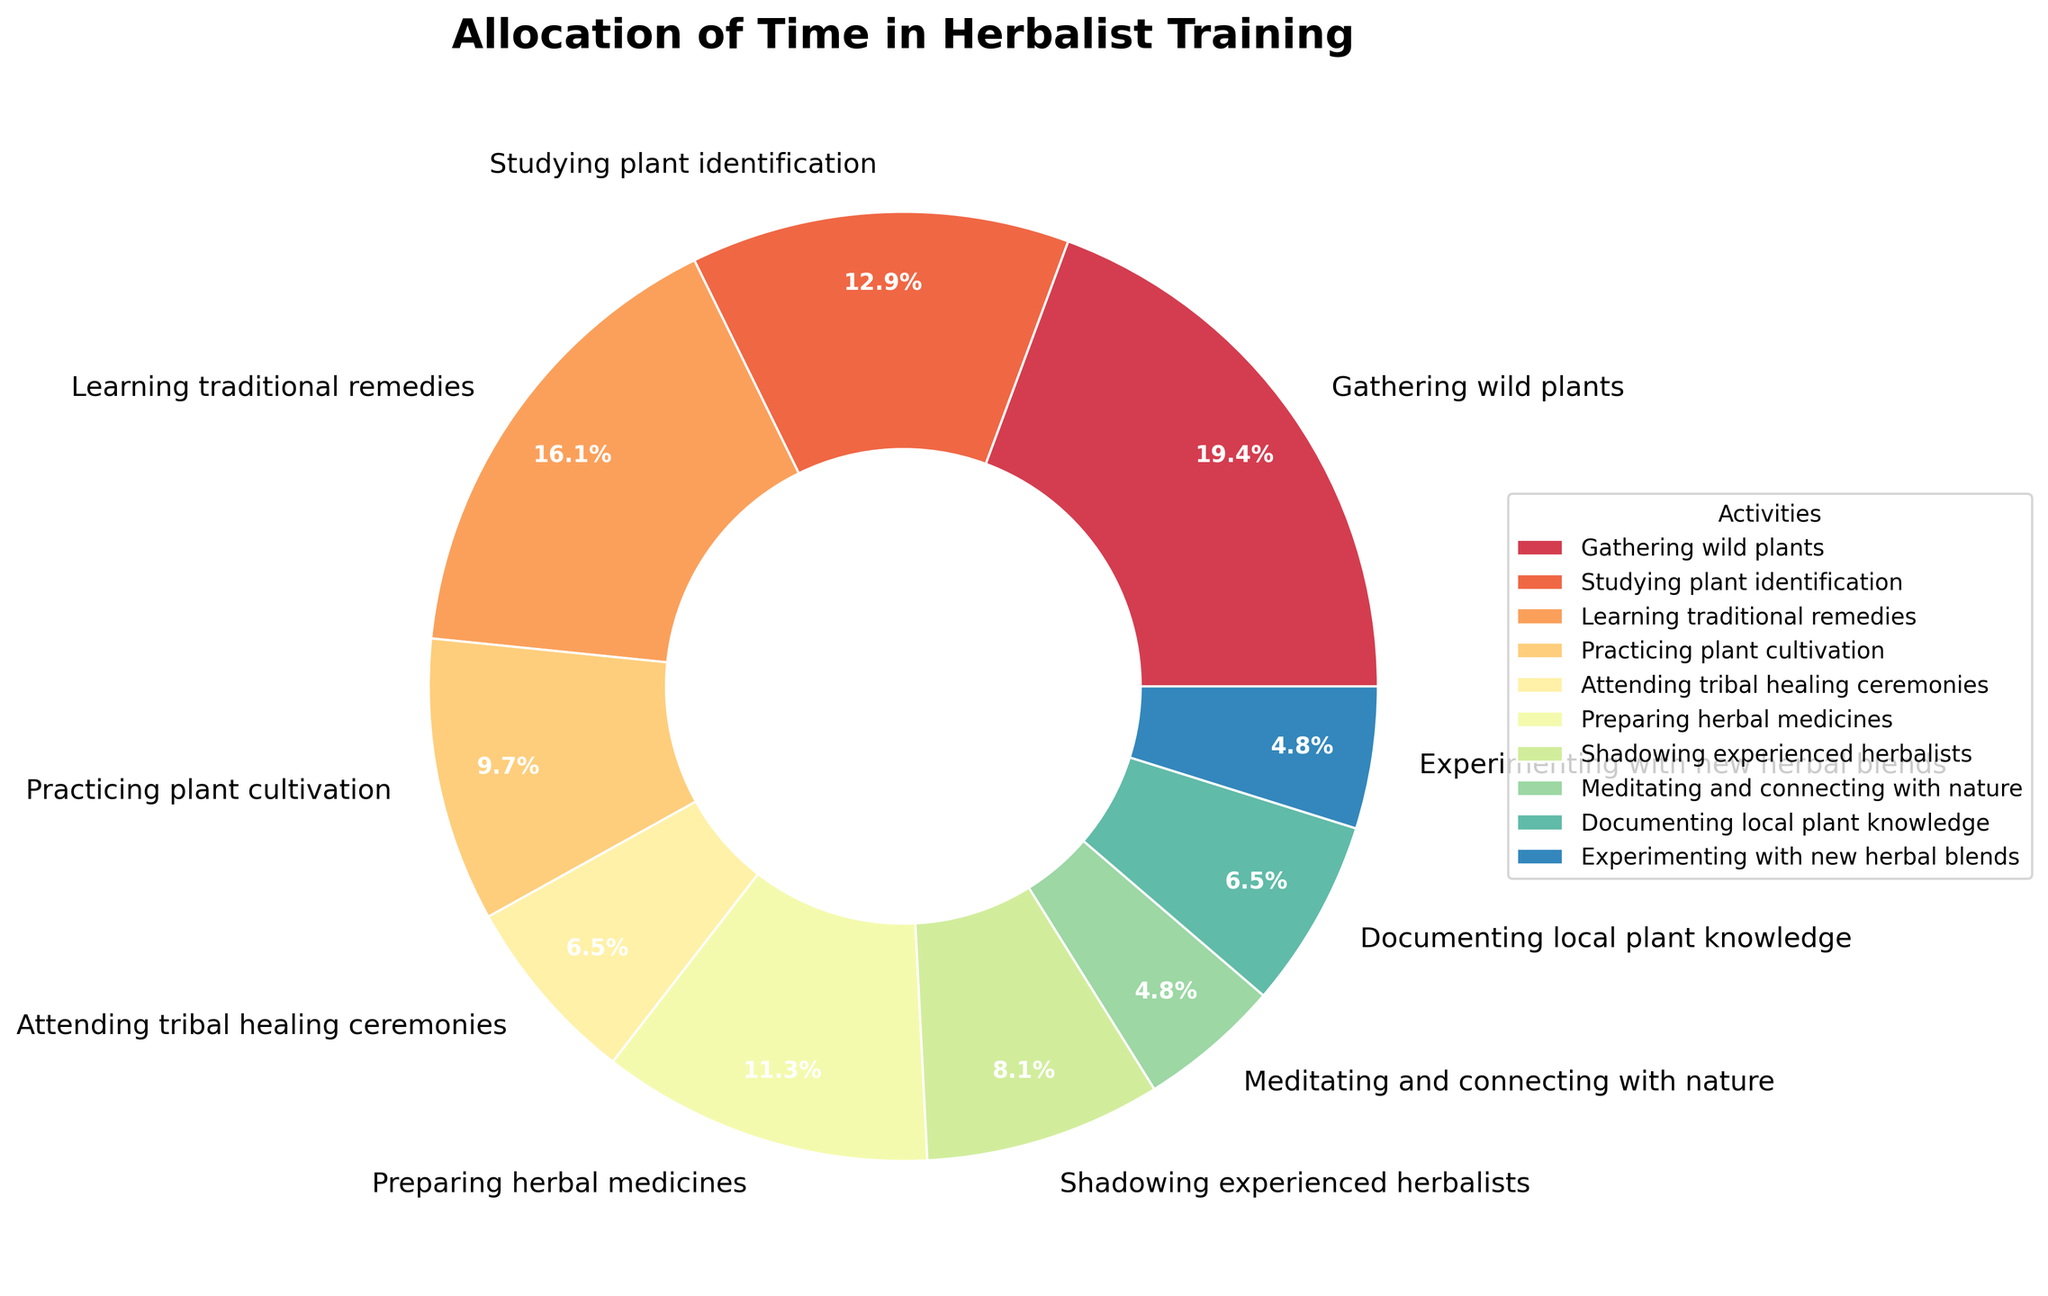What percentage of time is spent on gathering wild plants? Identify the section labeled "Gathering wild plants" on the pie chart and read the percentage inside it.
Answer: 20.0% Which activity takes more time, learning traditional remedies or preparing herbal medicines? Compare the percentages of the two activities: "Learning traditional remedies" and "Preparing herbal medicines."
Answer: Learning traditional remedies How many hours per week in total are spent on gathering wild plants and practicing plant cultivation? Add the hours dedicated to these two activities: 12 hours for gathering wild plants and 6 hours for practicing plant cultivation.
Answer: 18 hours Which activity has the smallest percentage of time allocated? Look for the activity on the pie chart with the smallest slice, which corresponds to the smallest percentage.
Answer: Meditating and connecting with nature Compare the time spent on shadowing experienced herbalists versus documenting local plant knowledge. Which one is greater? Compare the percentages of "Shadowing experienced herbalists" and "Documenting local plant knowledge." One has 5 hours, the other has 4 hours.
Answer: Shadowing experienced herbalists What is the difference in hours per week between studying plant identification and experimenting with new herbal blends? Subtract the hours for experimenting with new herbal blends (3) from the hours for studying plant identification (8).
Answer: 5 hours What are the main colors used in the pie chart to represent the activities? Identify and list the dominant colors used to differentiate different sections in the pie chart.
Answer: Various shades of the spectral range If we combine the hours for preparing herbal medicines and attending tribal healing ceremonies, what percentage of the total time does this represent? Sum the hours (7 for preparing herbal medicines and 4 for attending tribal healing ceremonies), then divide by the total sum (62 hours), and multiply by 100 to find the percentage.
Answer: 17.7% Which activity has a wider wedge, attending tribal healing ceremonies or meditating and connecting with nature? Compare the wedge sizes of these two sections on the pie chart.
Answer: Attending tribal healing ceremonies How does the time spent on documenting local plant knowledge compare to preparing herbal medicines percentage-wise? Compare the percentage slices designated for "Documenting local plant knowledge" and "Preparing herbal medicines" on the plot.
Answer: Preparing herbal medicines What is the combined percentage of time spent on attending tribal healing ceremonies and shadowing experienced herbalists? Add the percentages for both activities seen on the pie chart: 6.5% for attending tribal healing ceremonies and 8.1% for shadowing experienced herbalists.
Answer: 21.1% 